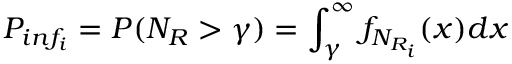<formula> <loc_0><loc_0><loc_500><loc_500>P _ { i n f _ { i } } = P ( N _ { R } > \gamma ) = \int _ { \gamma } ^ { \infty } f _ { N _ { R _ { i } } } ( x ) d x \,</formula> 